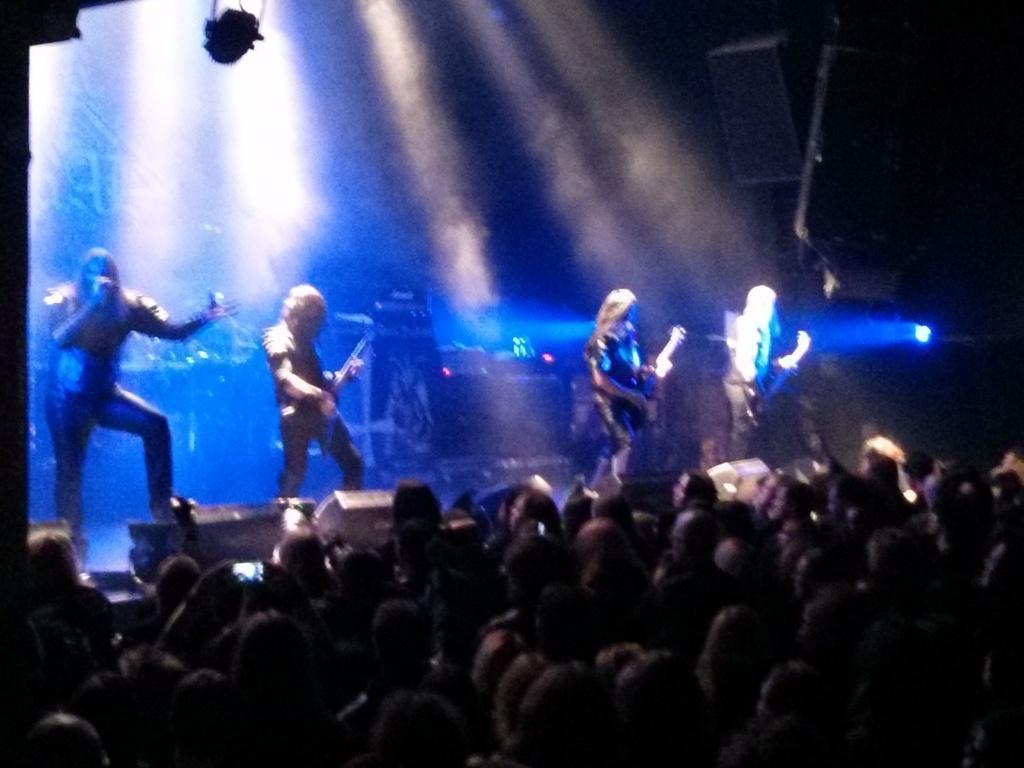In one or two sentences, can you explain what this image depicts? At the top of the image we can see persons on the dais and holding musical instruments in their hands. At the bottom of the image we can see a crowd standing. 